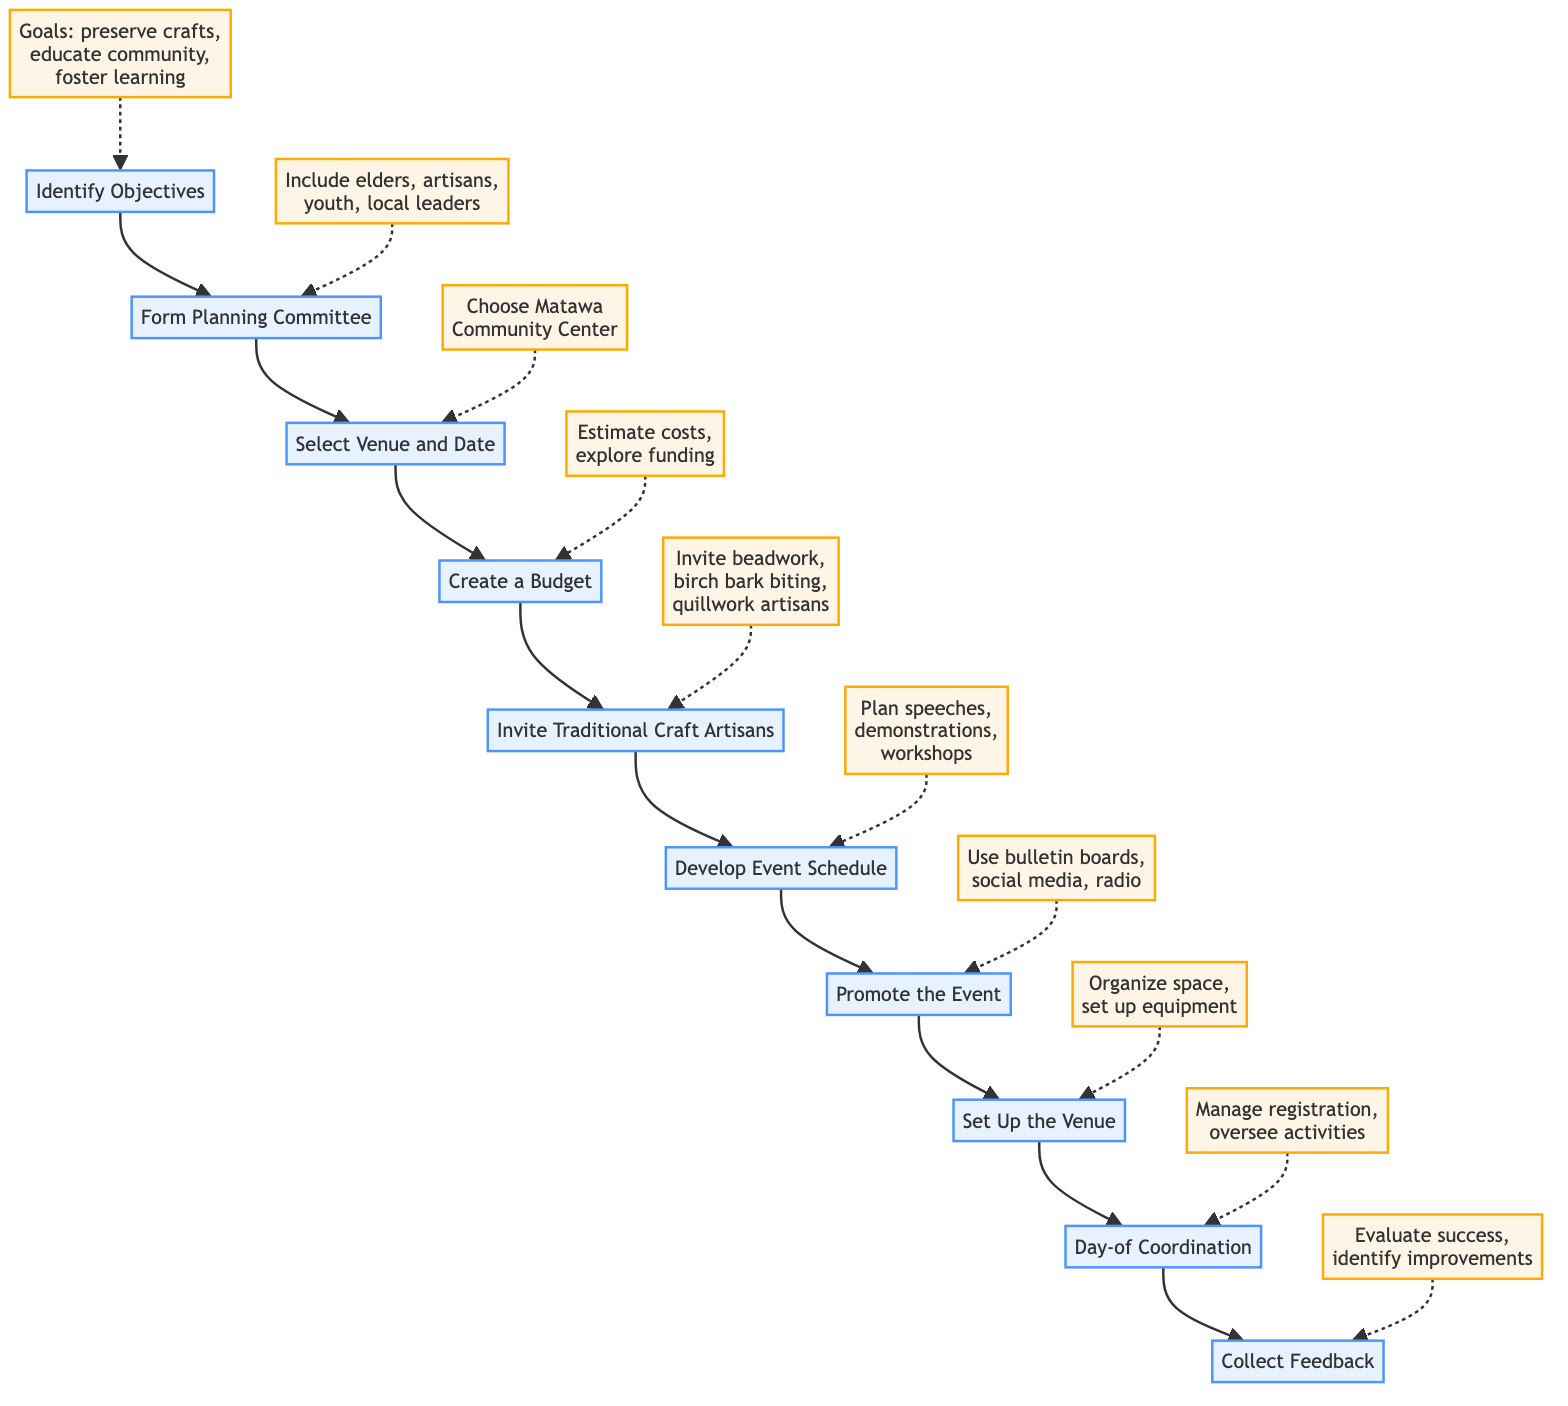What is the first step in organizing the event? The diagram indicates that the first step is "Identify Objectives," which is the starting point of the flow chart.
Answer: Identify Objectives How many main steps are involved in the flow chart? Counting the steps outlined in the flow chart, there are ten main steps from "Identify Objectives" to "Collect Feedback."
Answer: 10 What is the last step after "Day-of Coordination"? The flow chart shows that after "Day-of Coordination," the next step is "Collect Feedback," which concludes the planning and execution process.
Answer: Collect Feedback What group should be included in the planning committee? The details specify that the planning committee should include elders, artisans, youth, and local leaders, focusing on diverse representation from the community.
Answer: Elders, artisans, youth, local leaders Which step involves sending invitations to artisans? The document clearly states that the step "Invite Traditional Craft Artisans" is focused on reaching out to local artisans skilled in traditional crafts.
Answer: Invite Traditional Craft Artisans What is the purpose of the "Create a Budget" step? The "Create a Budget" step is aimed at estimating costs for various event aspects and exploring funding opportunities, ensuring financial preparation for the event.
Answer: Estimate costs, explore funding How is the venue set up for the event? In the step "Set Up the Venue," it details that the space should be organized with tables, chairs, workshop areas, and exhibition spaces, including arrangements for audio-visual equipment if necessary.
Answer: Organize space, set up equipment Which step comes immediately after "Promote the Event"? The sequence in the flow chart indicates that "Set Up the Venue" follows "Promote the Event," as part of the logistical preparations for the event.
Answer: Set Up the Venue What kind of feedback is collected at the end? The final step, "Collect Feedback," involves gathering insights from participants, artisans, and volunteers to evaluate the event's success and identify areas for future improvement.
Answer: Evaluate success, identify improvements 